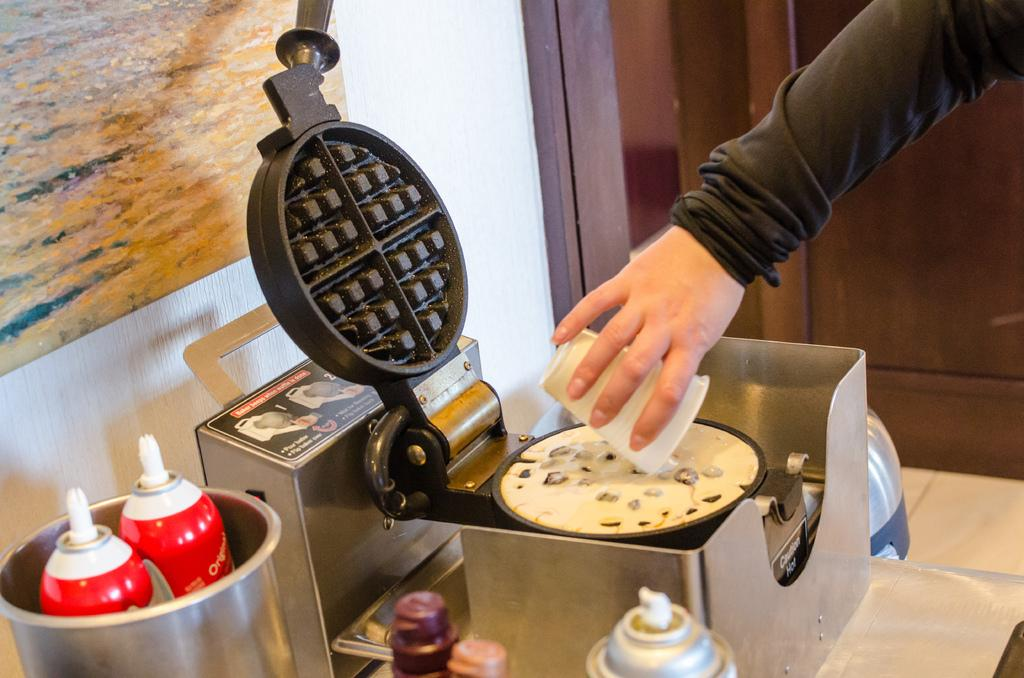What is the main subject of the image? There is a person in the image. What is the person holding in his hand? The person is holding a cup in his hand. What other objects can be seen in the image? There is a machine, bottles, and a frame on the wall in the image. How are the bottles arranged in the image? There are bottles in a dish in the image. What type of bag is the person carrying in the image? There is no bag visible in the image. How many balloons are tied to the frame on the wall? There are no balloons present in the image; only a frame on the wall is visible. 